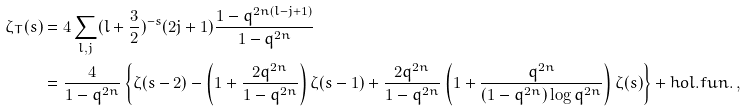<formula> <loc_0><loc_0><loc_500><loc_500>\zeta _ { T } ( s ) & = 4 \sum _ { l , j } ( l + \frac { 3 } { 2 } ) ^ { - s } ( 2 j + 1 ) \frac { 1 - q ^ { 2 n ( l - j + 1 ) } } { 1 - q ^ { 2 n } } \\ & = \frac { 4 } { 1 - q ^ { 2 n } } \left \{ \zeta ( s - 2 ) - \left ( 1 + \frac { 2 q ^ { 2 n } } { 1 - q ^ { 2 n } } \right ) \zeta ( s - 1 ) + \frac { 2 q ^ { 2 n } } { 1 - q ^ { 2 n } } \left ( 1 + \frac { q ^ { 2 n } } { ( 1 - q ^ { 2 n } ) \log q ^ { 2 n } } \right ) \zeta ( s ) \right \} + h o l . f u n . \, ,</formula> 